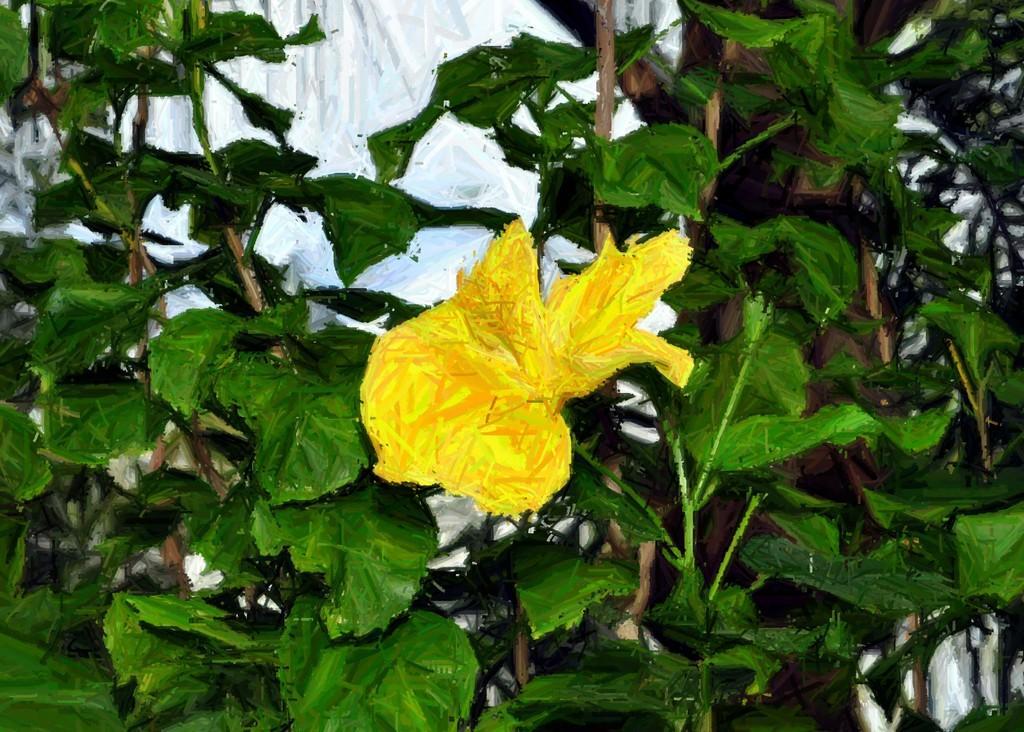Can you describe this image briefly? In this picture we can see the printed image. In front we can see yellow color flower and green leafs. 